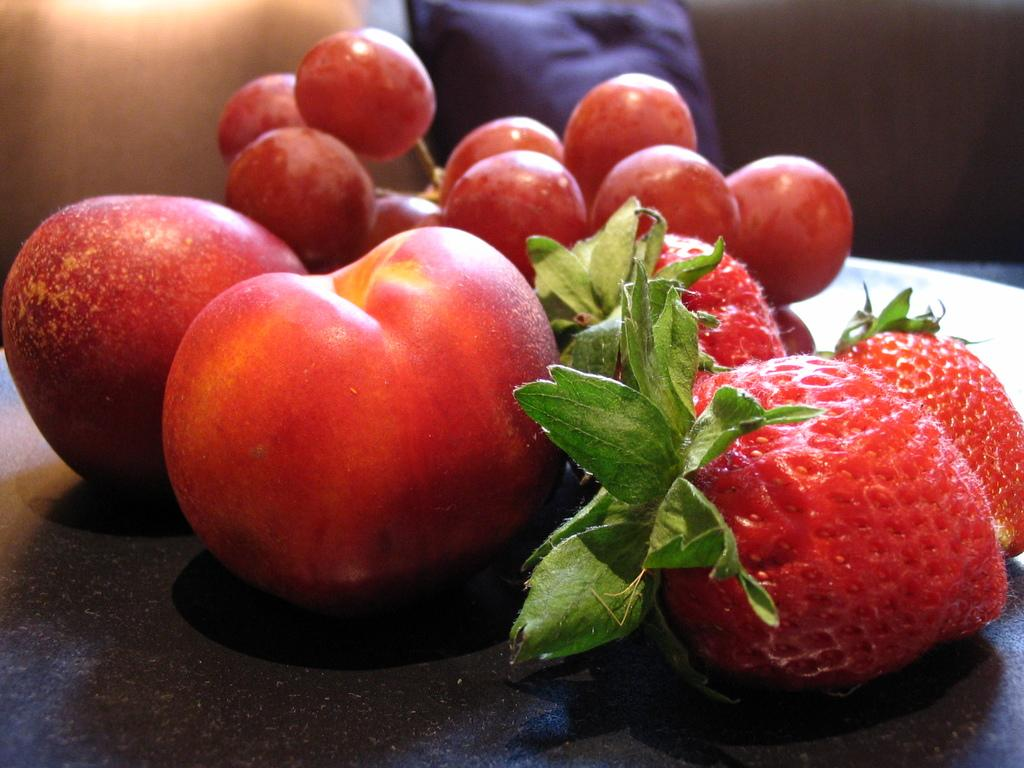What type of food can be seen in the image? There are fruits in the image. Where are the fruits located in the image? The fruits are in the center of the image. Can you describe the background of the image? The background of the image is blurry. What type of cream is being traded by the pigs in the image? There are no pigs or cream present in the image; it features fruits in the center of the image with a blurry background. 